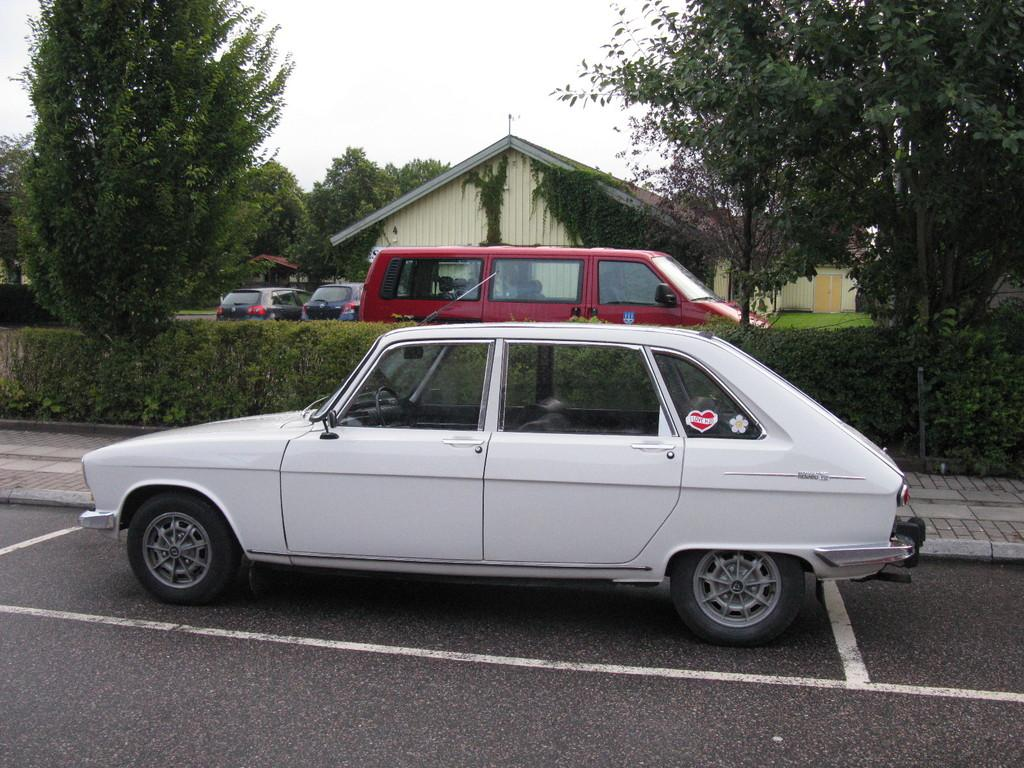What types of objects are present in the image? There are vehicles, trees, plants, and houses in the image. What type of vegetation can be seen in the image? There are trees and plants in the image. What type of ground surface is visible in the image? There is grass in the image. What parts of the natural environment are visible in the image? The ground and the sky are visible in the image. What type of insurance is required for the vehicles in the image? The image does not provide information about insurance requirements for the vehicles. Can you see any parts of the vehicles being smashed in the image? There is no indication of any damage or smashing to the vehicles in the image. 